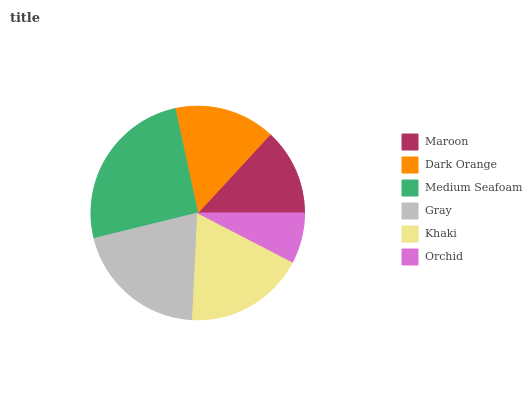Is Orchid the minimum?
Answer yes or no. Yes. Is Medium Seafoam the maximum?
Answer yes or no. Yes. Is Dark Orange the minimum?
Answer yes or no. No. Is Dark Orange the maximum?
Answer yes or no. No. Is Dark Orange greater than Maroon?
Answer yes or no. Yes. Is Maroon less than Dark Orange?
Answer yes or no. Yes. Is Maroon greater than Dark Orange?
Answer yes or no. No. Is Dark Orange less than Maroon?
Answer yes or no. No. Is Khaki the high median?
Answer yes or no. Yes. Is Dark Orange the low median?
Answer yes or no. Yes. Is Medium Seafoam the high median?
Answer yes or no. No. Is Maroon the low median?
Answer yes or no. No. 